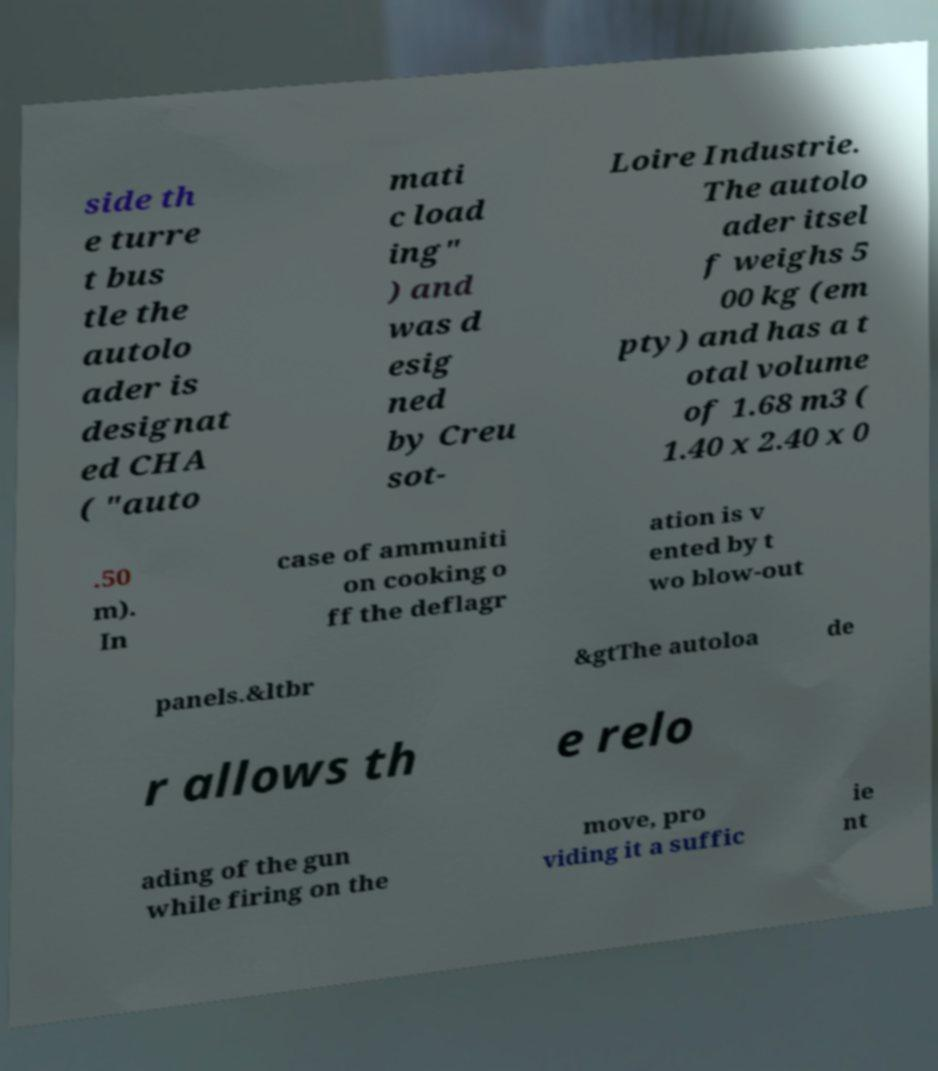Can you accurately transcribe the text from the provided image for me? side th e turre t bus tle the autolo ader is designat ed CHA ( "auto mati c load ing" ) and was d esig ned by Creu sot- Loire Industrie. The autolo ader itsel f weighs 5 00 kg (em pty) and has a t otal volume of 1.68 m3 ( 1.40 x 2.40 x 0 .50 m). In case of ammuniti on cooking o ff the deflagr ation is v ented by t wo blow-out panels.&ltbr &gtThe autoloa de r allows th e relo ading of the gun while firing on the move, pro viding it a suffic ie nt 